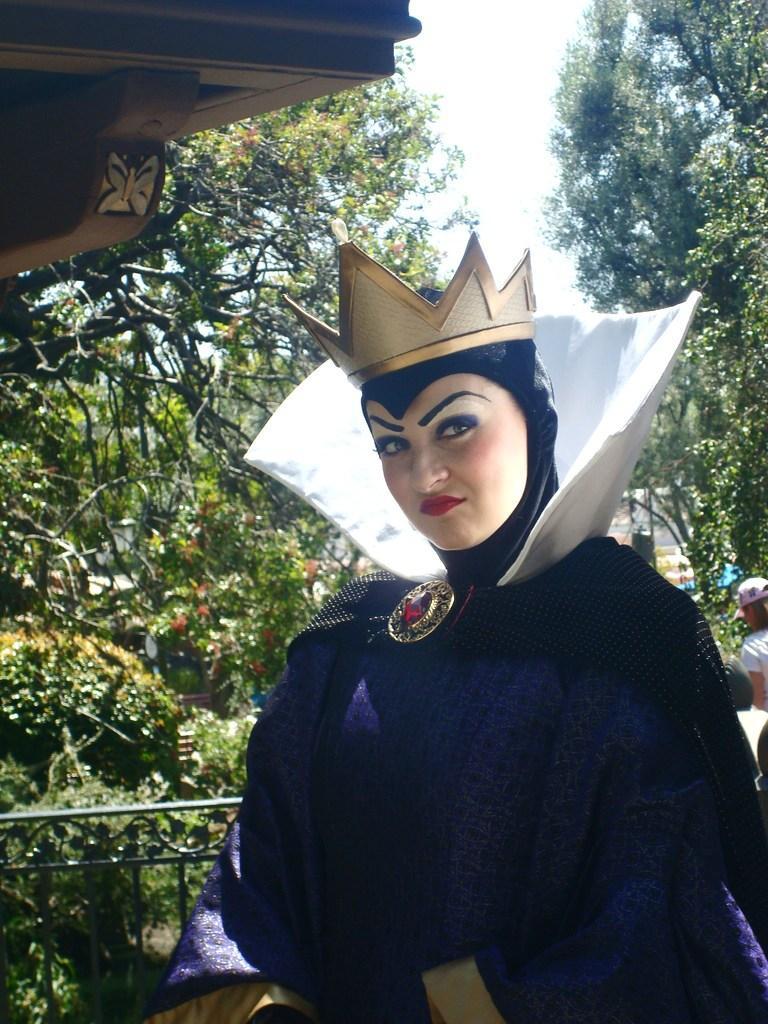In one or two sentences, can you explain what this image depicts? In this image we can see two persons, one of them is wearing a different costume, and a crown, there are plants, trees, there is a railing, and slab, also we can see the sky. 